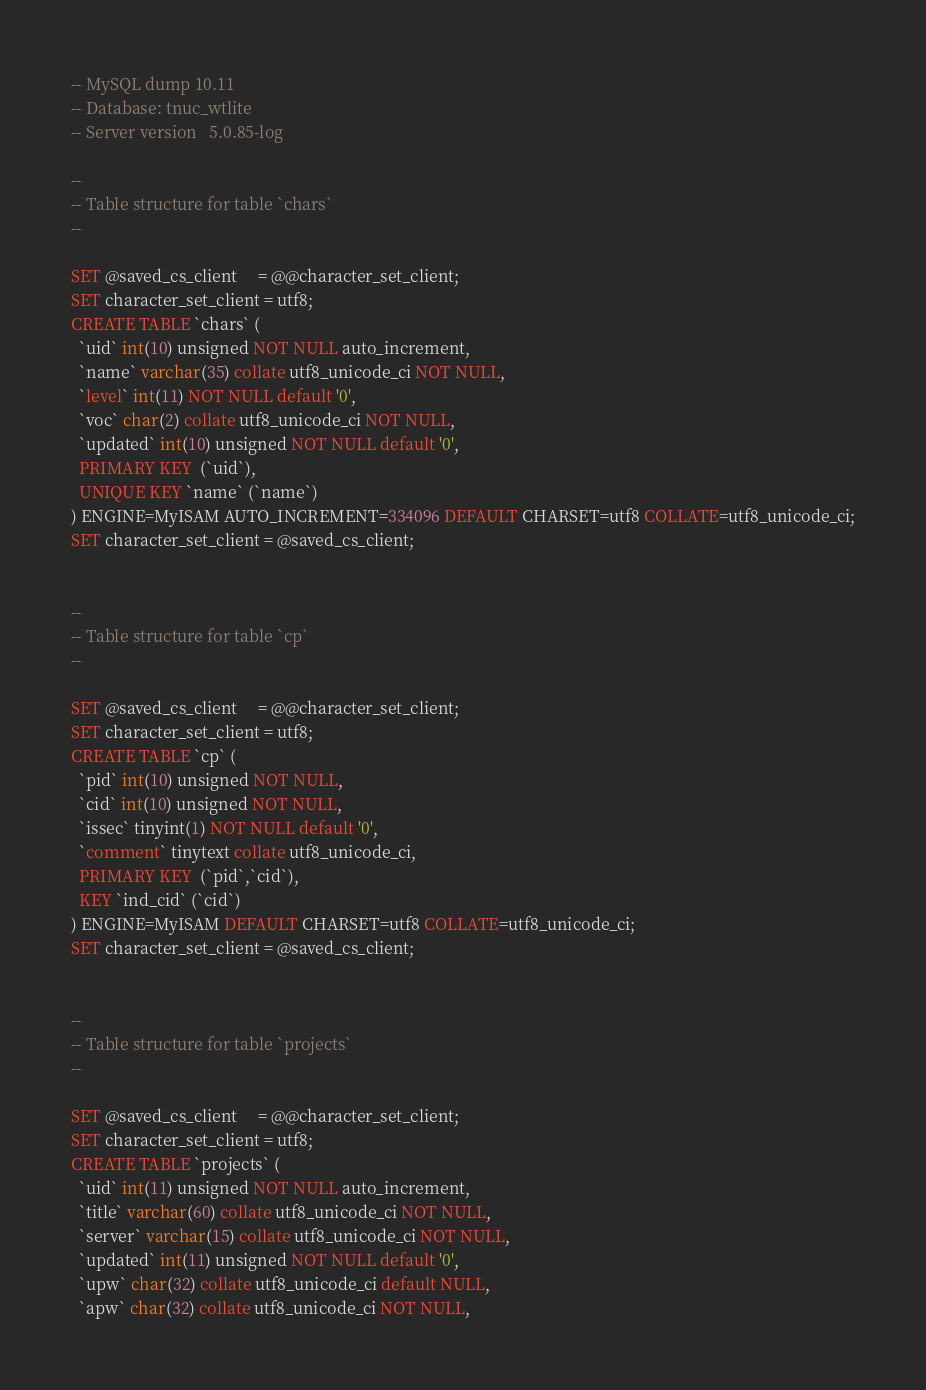<code> <loc_0><loc_0><loc_500><loc_500><_SQL_>-- MySQL dump 10.11
-- Database: tnuc_wtlite
-- Server version	5.0.85-log

--
-- Table structure for table `chars`
--

SET @saved_cs_client     = @@character_set_client;
SET character_set_client = utf8;
CREATE TABLE `chars` (
  `uid` int(10) unsigned NOT NULL auto_increment,
  `name` varchar(35) collate utf8_unicode_ci NOT NULL,
  `level` int(11) NOT NULL default '0',
  `voc` char(2) collate utf8_unicode_ci NOT NULL,
  `updated` int(10) unsigned NOT NULL default '0',
  PRIMARY KEY  (`uid`),
  UNIQUE KEY `name` (`name`)
) ENGINE=MyISAM AUTO_INCREMENT=334096 DEFAULT CHARSET=utf8 COLLATE=utf8_unicode_ci;
SET character_set_client = @saved_cs_client;


--
-- Table structure for table `cp`
--

SET @saved_cs_client     = @@character_set_client;
SET character_set_client = utf8;
CREATE TABLE `cp` (
  `pid` int(10) unsigned NOT NULL,
  `cid` int(10) unsigned NOT NULL,
  `issec` tinyint(1) NOT NULL default '0',
  `comment` tinytext collate utf8_unicode_ci,
  PRIMARY KEY  (`pid`,`cid`),
  KEY `ind_cid` (`cid`)
) ENGINE=MyISAM DEFAULT CHARSET=utf8 COLLATE=utf8_unicode_ci;
SET character_set_client = @saved_cs_client;


--
-- Table structure for table `projects`
--

SET @saved_cs_client     = @@character_set_client;
SET character_set_client = utf8;
CREATE TABLE `projects` (
  `uid` int(11) unsigned NOT NULL auto_increment,
  `title` varchar(60) collate utf8_unicode_ci NOT NULL,
  `server` varchar(15) collate utf8_unicode_ci NOT NULL,
  `updated` int(11) unsigned NOT NULL default '0',
  `upw` char(32) collate utf8_unicode_ci default NULL,
  `apw` char(32) collate utf8_unicode_ci NOT NULL,</code> 